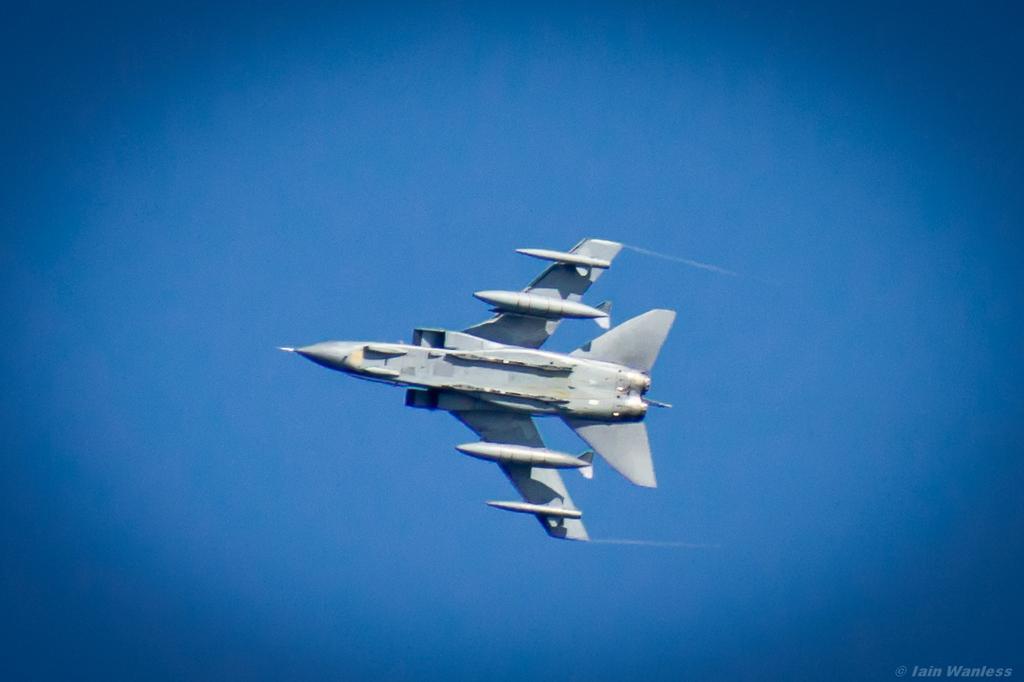In one or two sentences, can you explain what this image depicts? In this image, we can see an aircraft flying in the sky. 